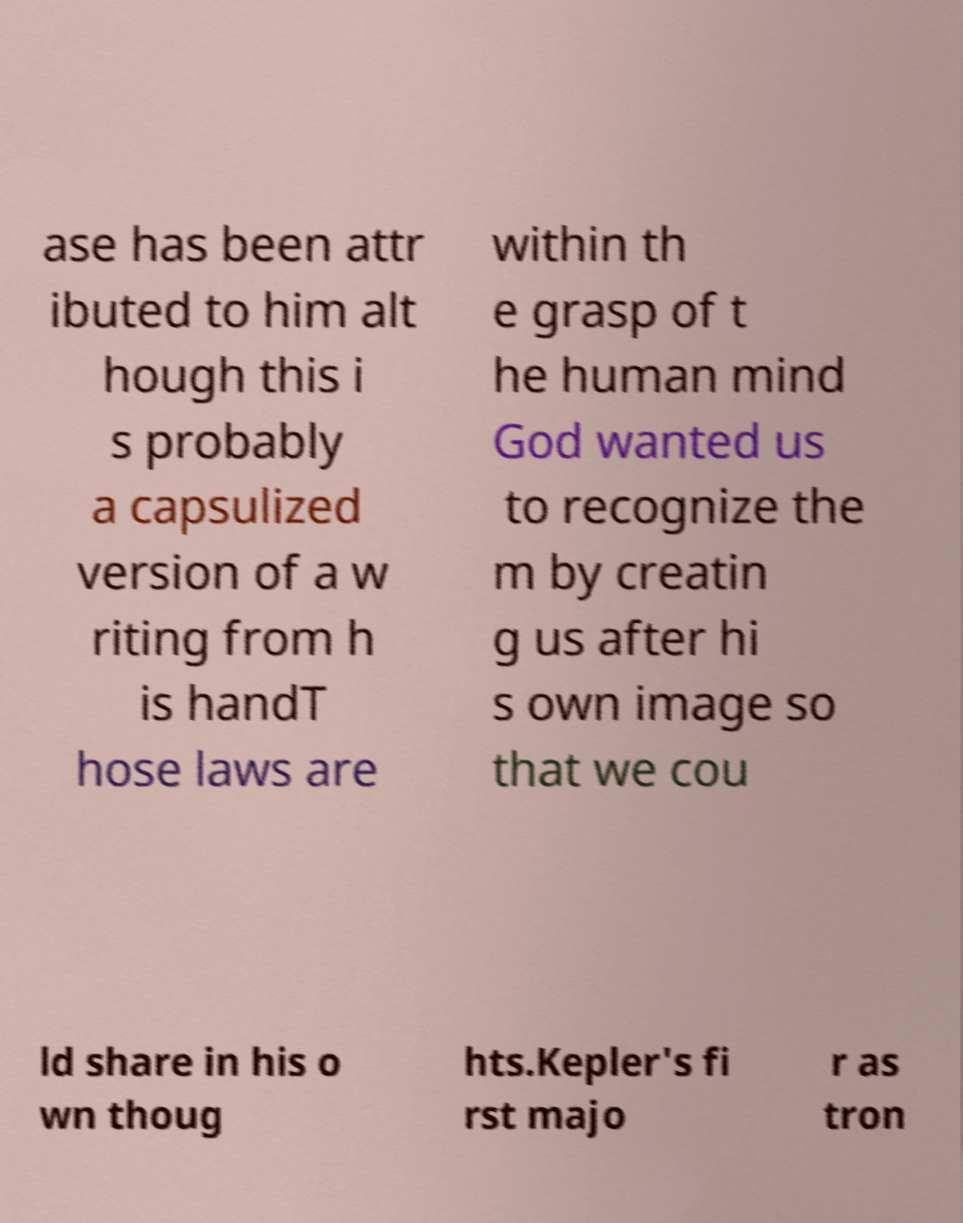Please read and relay the text visible in this image. What does it say? ase has been attr ibuted to him alt hough this i s probably a capsulized version of a w riting from h is handT hose laws are within th e grasp of t he human mind God wanted us to recognize the m by creatin g us after hi s own image so that we cou ld share in his o wn thoug hts.Kepler's fi rst majo r as tron 